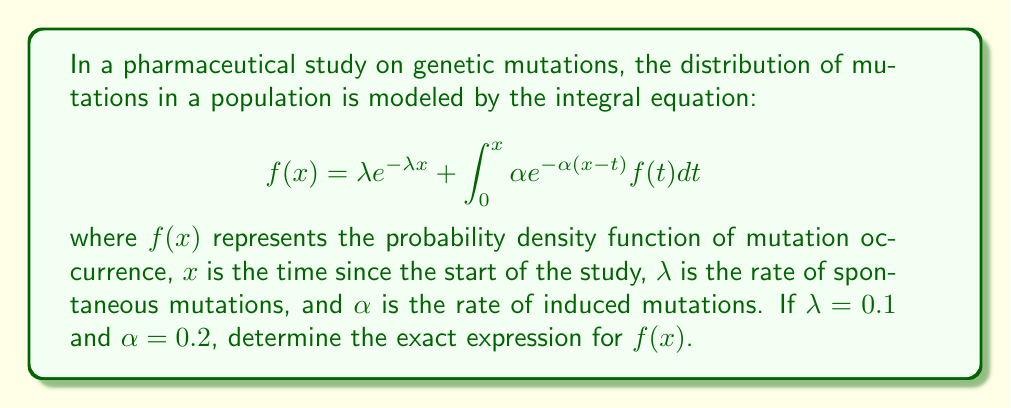Solve this math problem. To solve this integral equation, we'll use the Laplace transform method:

1) Take the Laplace transform of both sides of the equation:
   $$\mathcal{L}\{f(x)\} = \mathcal{L}\{\lambda e^{-\lambda x}\} + \mathcal{L}\{\int_0^x \alpha e^{-\alpha(x-t)} f(t) dt\}$$

2) Let $F(s) = \mathcal{L}\{f(x)\}$. Then:
   $$F(s) = \frac{\lambda}{s+\lambda} + \alpha F(s) \cdot \frac{1}{s+\alpha}$$

3) Solve for $F(s)$:
   $$F(s) = \frac{\lambda}{s+\lambda} + \frac{\alpha F(s)}{s+\alpha}$$
   $$F(s)(1 - \frac{\alpha}{s+\alpha}) = \frac{\lambda}{s+\lambda}$$
   $$F(s) = \frac{\lambda(s+\alpha)}{(s+\lambda)(s+\alpha) - \alpha}$$

4) Simplify:
   $$F(s) = \frac{\lambda(s+\alpha)}{s^2 + (\lambda+\alpha)s + \lambda\alpha - \alpha}$$
   $$F(s) = \frac{\lambda(s+\alpha)}{s^2 + (\lambda+\alpha)s + \lambda\alpha - \alpha}$$

5) Substitute the given values $\lambda = 0.1$ and $\alpha = 0.2$:
   $$F(s) = \frac{0.1(s+0.2)}{s^2 + 0.3s + 0.02 - 0.2} = \frac{0.1s + 0.02}{s^2 + 0.3s - 0.18}$$

6) To find $f(x)$, we need to take the inverse Laplace transform. The denominator can be factored as:
   $$(s^2 + 0.3s - 0.18) = (s + 0.6)(s - 0.3)$$

7) Using partial fraction decomposition:
   $$\frac{0.1s + 0.02}{(s + 0.6)(s - 0.3)} = \frac{A}{s + 0.6} + \frac{B}{s - 0.3}$$

8) Solving for A and B:
   $$A = \frac{0.1(0.6) + 0.02}{0.6 + 0.3} = 0.08$$
   $$B = \frac{0.1(-0.3) + 0.02}{-0.3 - 0.6} = 0.02$$

9) Therefore:
   $$F(s) = \frac{0.08}{s + 0.6} + \frac{0.02}{s - 0.3}$$

10) Taking the inverse Laplace transform:
    $$f(x) = 0.08e^{-0.6x} + 0.02e^{0.3x}$$

This is the exact expression for $f(x)$.
Answer: $f(x) = 0.08e^{-0.6x} + 0.02e^{0.3x}$ 